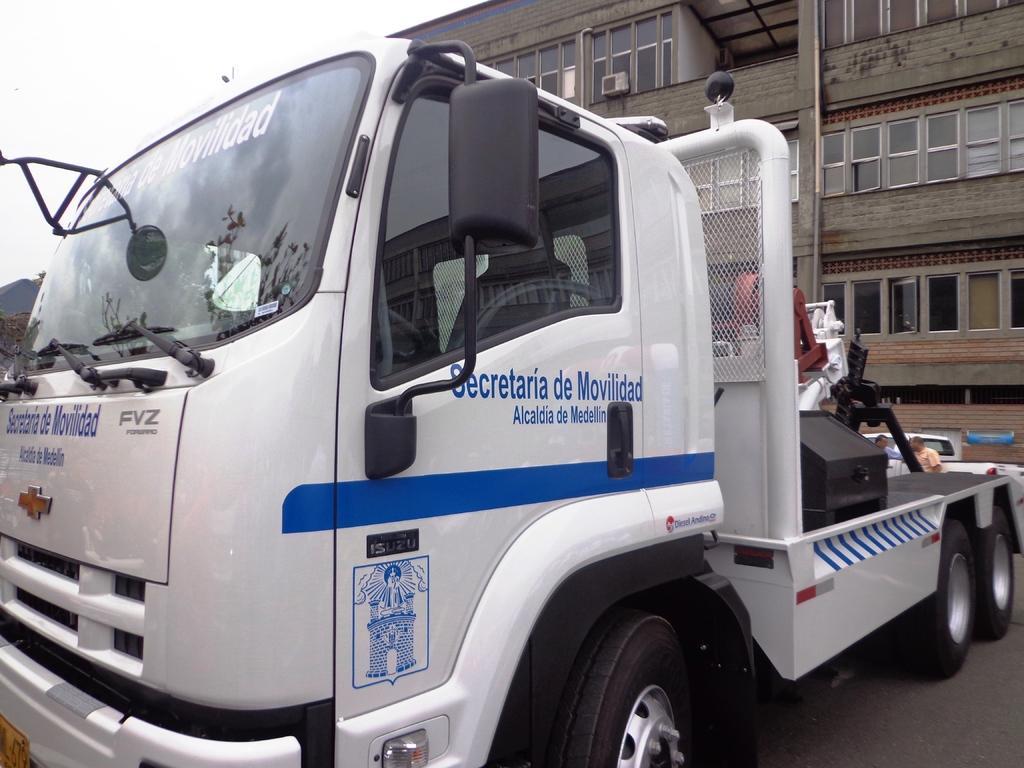How would you summarize this image in a sentence or two? This picture contains a white color vehicle with some text written on it. Behind the vehicle, we see two men standing beside the white car and behind that, we see a building in light brown color. At the top of the picture, we see the sky. This picture is clicked outside the city. 